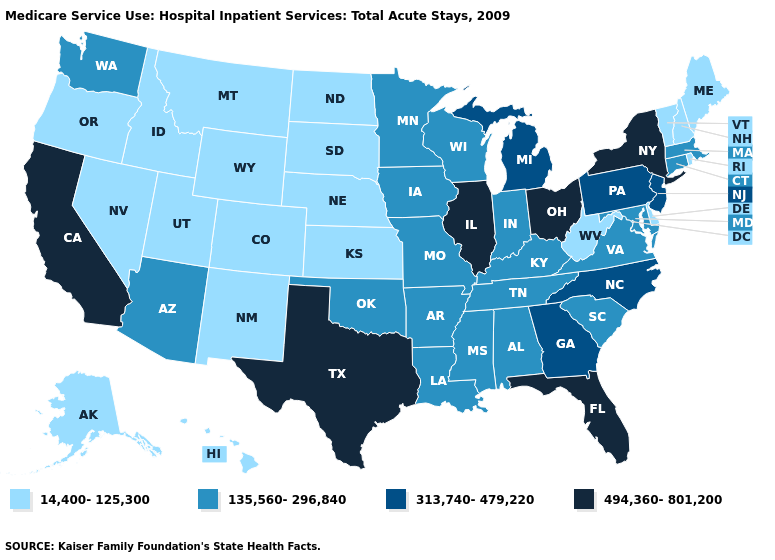What is the value of Indiana?
Give a very brief answer. 135,560-296,840. What is the highest value in states that border Kentucky?
Write a very short answer. 494,360-801,200. Is the legend a continuous bar?
Write a very short answer. No. What is the value of North Dakota?
Concise answer only. 14,400-125,300. Name the states that have a value in the range 494,360-801,200?
Be succinct. California, Florida, Illinois, New York, Ohio, Texas. Name the states that have a value in the range 494,360-801,200?
Be succinct. California, Florida, Illinois, New York, Ohio, Texas. Does Vermont have the highest value in the USA?
Keep it brief. No. What is the highest value in the MidWest ?
Keep it brief. 494,360-801,200. What is the value of Connecticut?
Concise answer only. 135,560-296,840. Among the states that border Virginia , which have the highest value?
Be succinct. North Carolina. What is the value of West Virginia?
Answer briefly. 14,400-125,300. How many symbols are there in the legend?
Concise answer only. 4. Does the map have missing data?
Give a very brief answer. No. Which states hav the highest value in the MidWest?
Concise answer only. Illinois, Ohio. 